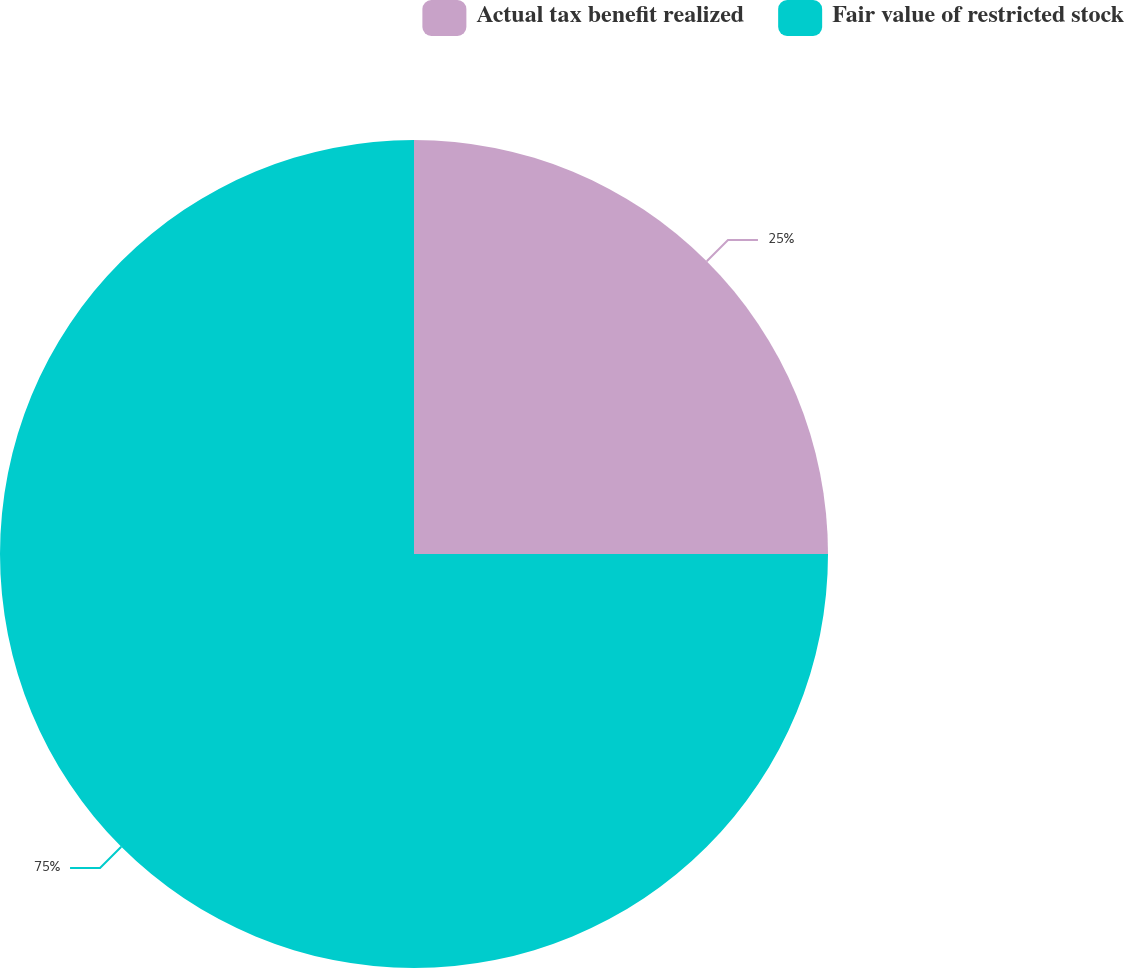<chart> <loc_0><loc_0><loc_500><loc_500><pie_chart><fcel>Actual tax benefit realized<fcel>Fair value of restricted stock<nl><fcel>25.0%<fcel>75.0%<nl></chart> 